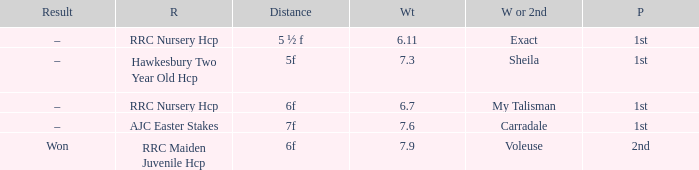What is the the name of the winner or 2nd  with a weight more than 7.3, and the result was –? Carradale. 